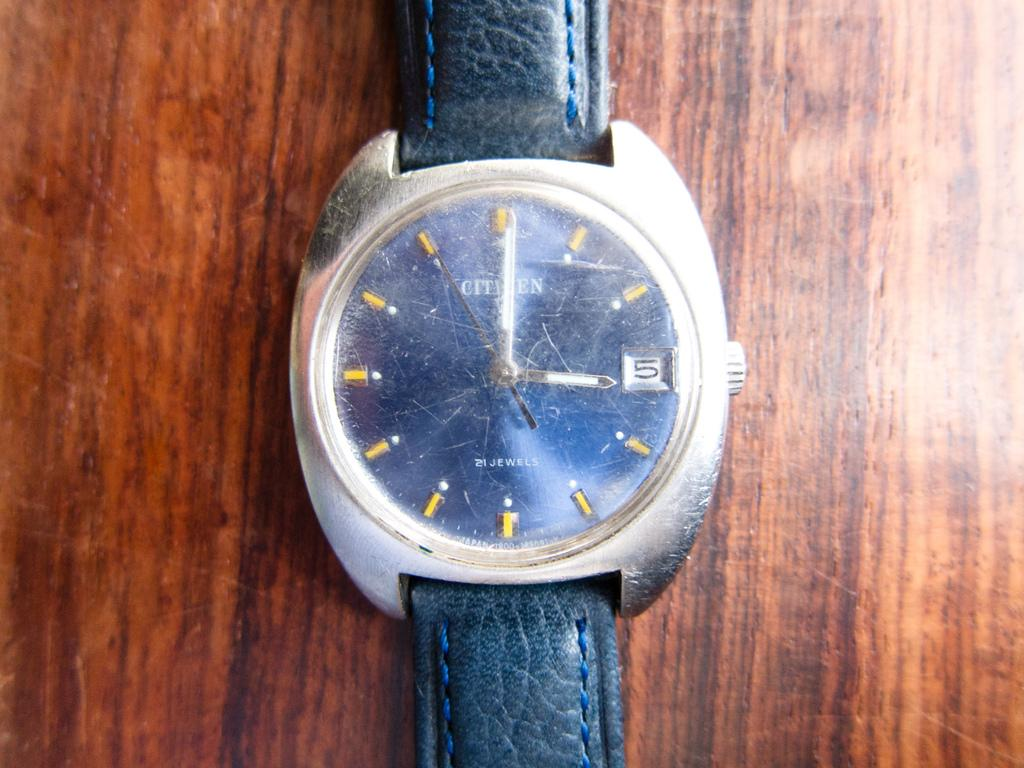<image>
Create a compact narrative representing the image presented. A bleary watch which has the time set as three and the number 5 visible. 